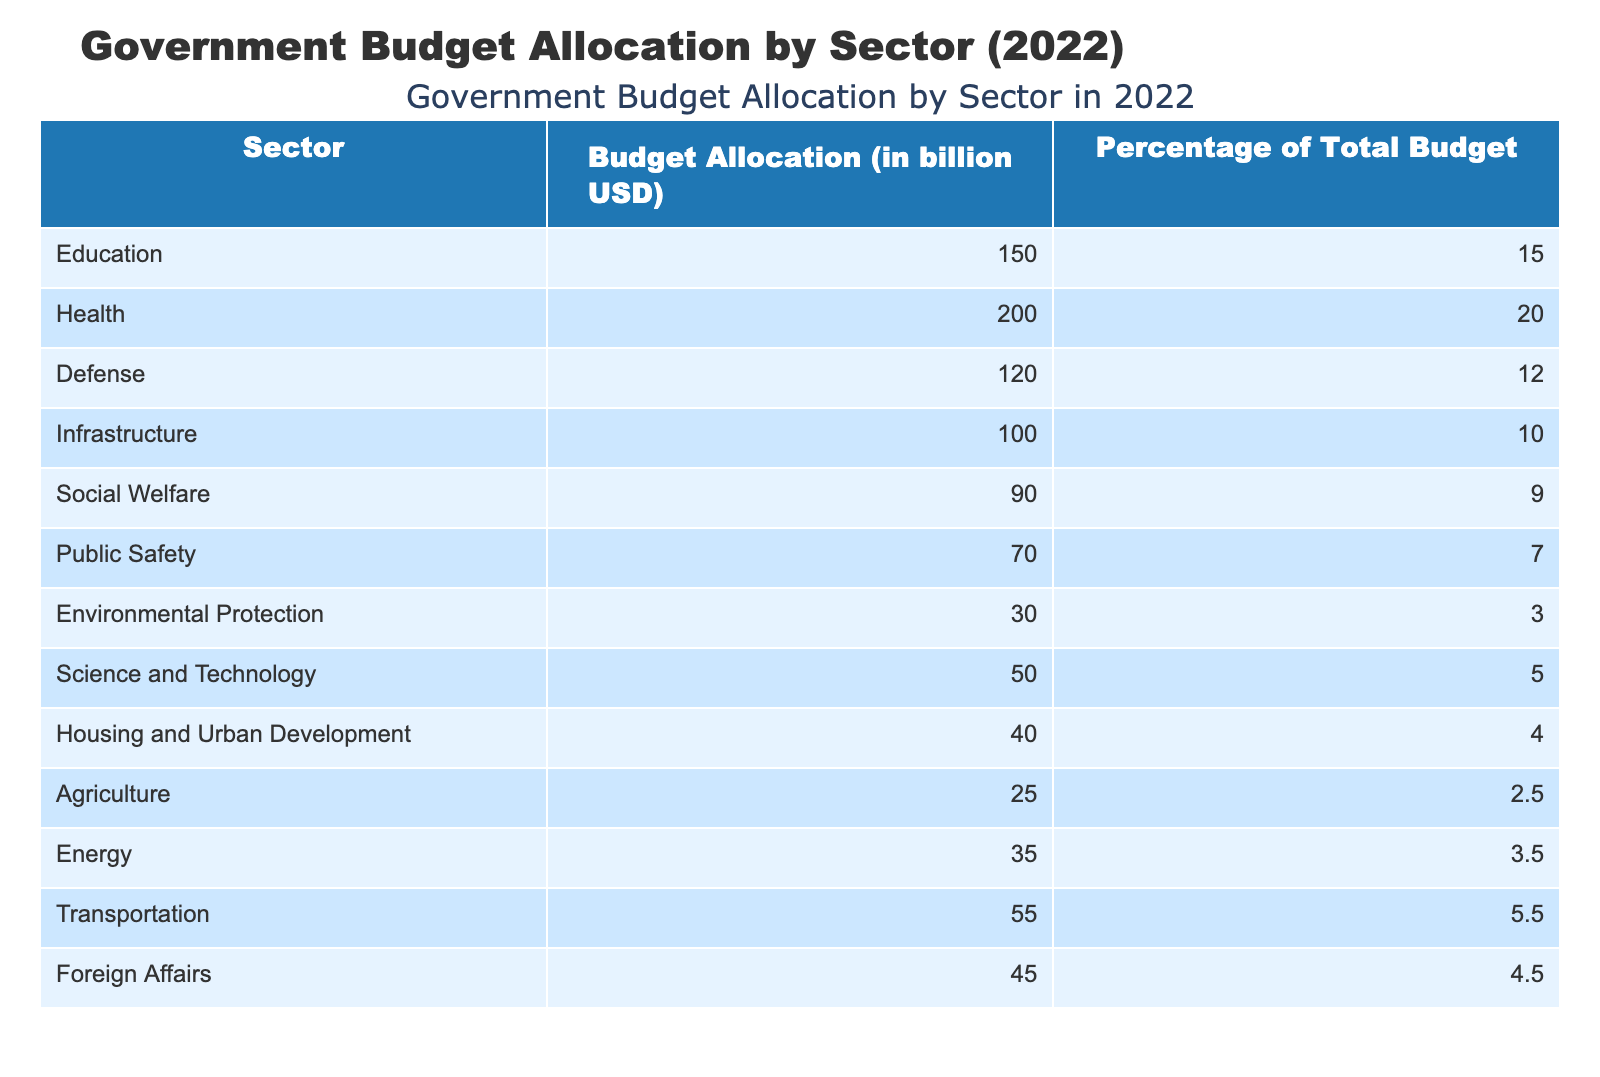What is the budget allocation for Health? The table shows a specific row for Health with a corresponding budget allocation. Looking at the row under the column "Budget Allocation (in billion USD)", it indicates that Health receives 200 billion USD.
Answer: 200 billion USD Which sector has the highest budget allocation? By checking the budget allocation values for each sector, the highest amount is in the Health sector, which is 200 billion USD.
Answer: Health How much more is allocated to Education than to Agriculture? The budget allocation for Education is 150 billion USD and for Agriculture it is 25 billion USD. The difference is calculated as 150 - 25 = 125 billion USD.
Answer: 125 billion USD What percentage of the total budget is allocated to Defense and Infrastructure combined? The budget allocation for Defense is 120 billion USD (12%) and for Infrastructure is 100 billion USD (10%). Adding these percentages together: 12 + 10 = 22 percent.
Answer: 22 percent Is the allocation for Environmental Protection greater than that for Public Safety? The allocation for Environmental Protection is 30 billion USD while for Public Safety it is 70 billion USD. Comparing these values shows that 30 is less than 70, thus the statement is false.
Answer: No What is the total budget allocation for all sectors listed? Adding up all the budget allocations from the table: 150 + 200 + 120 + 100 + 90 + 70 + 30 + 50 + 40 + 25 + 35 + 55 + 45 equals a total of 1,010 billion USD.
Answer: 1,010 billion USD How much budget is allocated to Social Welfare compared to Science and Technology? Social Welfare has a budget allocation of 90 billion USD and Science and Technology has 50 billion USD. The difference is calculated as 90 - 50 = 40 billion USD, indicating Social Welfare has a higher allocation.
Answer: 40 billion USD Which sector receives a smaller budget: Energy or Housing and Urban Development? Energy has a budget of 35 billion USD whereas Housing and Urban Development has 40 billion USD. Since 35 is less than 40, Energy receives a smaller budget.
Answer: Energy What is the average budget allocation among the sectors that receive more than 50 billion USD? The sectors with allocations over 50 billion USD are Health (200), Education (150), Defense (120), Infrastructure (100), and Transportation (55). Adding these gives a total of 625 billion USD. There are 5 sectors, so dividing: 625 / 5 = 125 billion USD.
Answer: 125 billion USD 